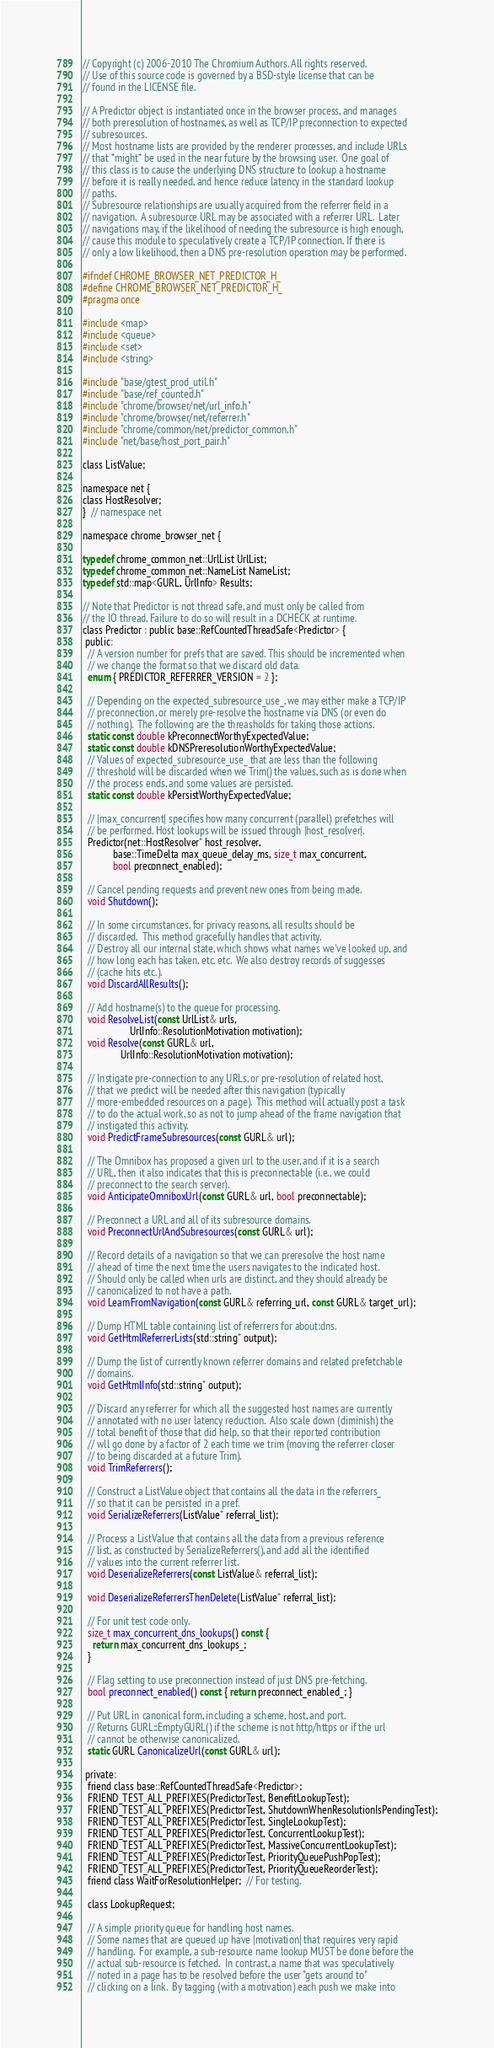Convert code to text. <code><loc_0><loc_0><loc_500><loc_500><_C_>// Copyright (c) 2006-2010 The Chromium Authors. All rights reserved.
// Use of this source code is governed by a BSD-style license that can be
// found in the LICENSE file.

// A Predictor object is instantiated once in the browser process, and manages
// both preresolution of hostnames, as well as TCP/IP preconnection to expected
// subresources.
// Most hostname lists are provided by the renderer processes, and include URLs
// that *might* be used in the near future by the browsing user.  One goal of
// this class is to cause the underlying DNS structure to lookup a hostname
// before it is really needed, and hence reduce latency in the standard lookup
// paths.
// Subresource relationships are usually acquired from the referrer field in a
// navigation.  A subresource URL may be associated with a referrer URL.  Later
// navigations may, if the likelihood of needing the subresource is high enough,
// cause this module to speculatively create a TCP/IP connection. If there is
// only a low likelihood, then a DNS pre-resolution operation may be performed.

#ifndef CHROME_BROWSER_NET_PREDICTOR_H_
#define CHROME_BROWSER_NET_PREDICTOR_H_
#pragma once

#include <map>
#include <queue>
#include <set>
#include <string>

#include "base/gtest_prod_util.h"
#include "base/ref_counted.h"
#include "chrome/browser/net/url_info.h"
#include "chrome/browser/net/referrer.h"
#include "chrome/common/net/predictor_common.h"
#include "net/base/host_port_pair.h"

class ListValue;

namespace net {
class HostResolver;
}  // namespace net

namespace chrome_browser_net {

typedef chrome_common_net::UrlList UrlList;
typedef chrome_common_net::NameList NameList;
typedef std::map<GURL, UrlInfo> Results;

// Note that Predictor is not thread safe, and must only be called from
// the IO thread. Failure to do so will result in a DCHECK at runtime.
class Predictor : public base::RefCountedThreadSafe<Predictor> {
 public:
  // A version number for prefs that are saved. This should be incremented when
  // we change the format so that we discard old data.
  enum { PREDICTOR_REFERRER_VERSION = 2 };

  // Depending on the expected_subresource_use_, we may either make a TCP/IP
  // preconnection, or merely pre-resolve the hostname via DNS (or even do
  // nothing).  The following are the threasholds for taking those actions.
  static const double kPreconnectWorthyExpectedValue;
  static const double kDNSPreresolutionWorthyExpectedValue;
  // Values of expected_subresource_use_ that are less than the following
  // threshold will be discarded when we Trim() the values, such as is done when
  // the process ends, and some values are persisted.
  static const double kPersistWorthyExpectedValue;

  // |max_concurrent| specifies how many concurrent (parallel) prefetches will
  // be performed. Host lookups will be issued through |host_resolver|.
  Predictor(net::HostResolver* host_resolver,
            base::TimeDelta max_queue_delay_ms, size_t max_concurrent,
            bool preconnect_enabled);

  // Cancel pending requests and prevent new ones from being made.
  void Shutdown();

  // In some circumstances, for privacy reasons, all results should be
  // discarded.  This method gracefully handles that activity.
  // Destroy all our internal state, which shows what names we've looked up, and
  // how long each has taken, etc. etc.  We also destroy records of suggesses
  // (cache hits etc.).
  void DiscardAllResults();

  // Add hostname(s) to the queue for processing.
  void ResolveList(const UrlList& urls,
                   UrlInfo::ResolutionMotivation motivation);
  void Resolve(const GURL& url,
               UrlInfo::ResolutionMotivation motivation);

  // Instigate pre-connection to any URLs, or pre-resolution of related host,
  // that we predict will be needed after this navigation (typically
  // more-embedded resources on a page).  This method will actually post a task
  // to do the actual work, so as not to jump ahead of the frame navigation that
  // instigated this activity.
  void PredictFrameSubresources(const GURL& url);

  // The Omnibox has proposed a given url to the user, and if it is a search
  // URL, then it also indicates that this is preconnectable (i.e., we could
  // preconnect to the search server).
  void AnticipateOmniboxUrl(const GURL& url, bool preconnectable);

  // Preconnect a URL and all of its subresource domains.
  void PreconnectUrlAndSubresources(const GURL& url);

  // Record details of a navigation so that we can preresolve the host name
  // ahead of time the next time the users navigates to the indicated host.
  // Should only be called when urls are distinct, and they should already be
  // canonicalized to not have a path.
  void LearnFromNavigation(const GURL& referring_url, const GURL& target_url);

  // Dump HTML table containing list of referrers for about:dns.
  void GetHtmlReferrerLists(std::string* output);

  // Dump the list of currently known referrer domains and related prefetchable
  // domains.
  void GetHtmlInfo(std::string* output);

  // Discard any referrer for which all the suggested host names are currently
  // annotated with no user latency reduction.  Also scale down (diminish) the
  // total benefit of those that did help, so that their reported contribution
  // wll go done by a factor of 2 each time we trim (moving the referrer closer
  // to being discarded at a future Trim).
  void TrimReferrers();

  // Construct a ListValue object that contains all the data in the referrers_
  // so that it can be persisted in a pref.
  void SerializeReferrers(ListValue* referral_list);

  // Process a ListValue that contains all the data from a previous reference
  // list, as constructed by SerializeReferrers(), and add all the identified
  // values into the current referrer list.
  void DeserializeReferrers(const ListValue& referral_list);

  void DeserializeReferrersThenDelete(ListValue* referral_list);

  // For unit test code only.
  size_t max_concurrent_dns_lookups() const {
    return max_concurrent_dns_lookups_;
  }

  // Flag setting to use preconnection instead of just DNS pre-fetching.
  bool preconnect_enabled() const { return preconnect_enabled_; }

  // Put URL in canonical form, including a scheme, host, and port.
  // Returns GURL::EmptyGURL() if the scheme is not http/https or if the url
  // cannot be otherwise canonicalized.
  static GURL CanonicalizeUrl(const GURL& url);

 private:
  friend class base::RefCountedThreadSafe<Predictor>;
  FRIEND_TEST_ALL_PREFIXES(PredictorTest, BenefitLookupTest);
  FRIEND_TEST_ALL_PREFIXES(PredictorTest, ShutdownWhenResolutionIsPendingTest);
  FRIEND_TEST_ALL_PREFIXES(PredictorTest, SingleLookupTest);
  FRIEND_TEST_ALL_PREFIXES(PredictorTest, ConcurrentLookupTest);
  FRIEND_TEST_ALL_PREFIXES(PredictorTest, MassiveConcurrentLookupTest);
  FRIEND_TEST_ALL_PREFIXES(PredictorTest, PriorityQueuePushPopTest);
  FRIEND_TEST_ALL_PREFIXES(PredictorTest, PriorityQueueReorderTest);
  friend class WaitForResolutionHelper;  // For testing.

  class LookupRequest;

  // A simple priority queue for handling host names.
  // Some names that are queued up have |motivation| that requires very rapid
  // handling.  For example, a sub-resource name lookup MUST be done before the
  // actual sub-resource is fetched.  In contrast, a name that was speculatively
  // noted in a page has to be resolved before the user "gets around to"
  // clicking on a link.  By tagging (with a motivation) each push we make into</code> 